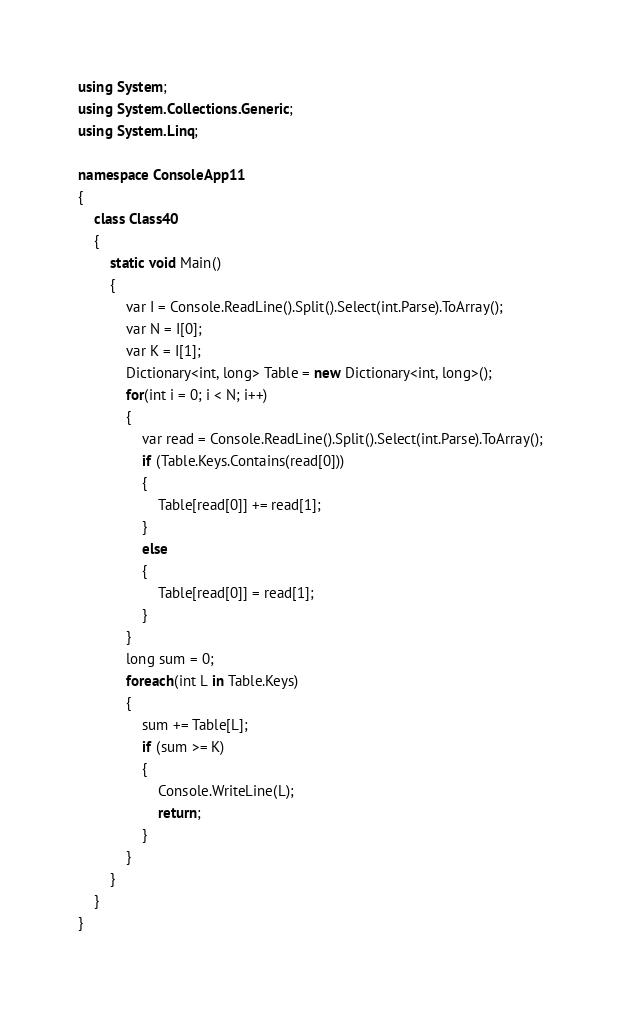Convert code to text. <code><loc_0><loc_0><loc_500><loc_500><_C#_>using System;
using System.Collections.Generic;
using System.Linq;

namespace ConsoleApp11
{
    class Class40
    {
        static void Main()
        {
            var I = Console.ReadLine().Split().Select(int.Parse).ToArray();
            var N = I[0];
            var K = I[1];
            Dictionary<int, long> Table = new Dictionary<int, long>();
            for(int i = 0; i < N; i++)
            {
                var read = Console.ReadLine().Split().Select(int.Parse).ToArray();
                if (Table.Keys.Contains(read[0]))
                {
                    Table[read[0]] += read[1];
                }
                else
                {
                    Table[read[0]] = read[1];
                }
            }
            long sum = 0;
            foreach(int L in Table.Keys)
            {
                sum += Table[L];
                if (sum >= K)
                {
                    Console.WriteLine(L);
                    return;
                }
            }
        }
    }
}
</code> 